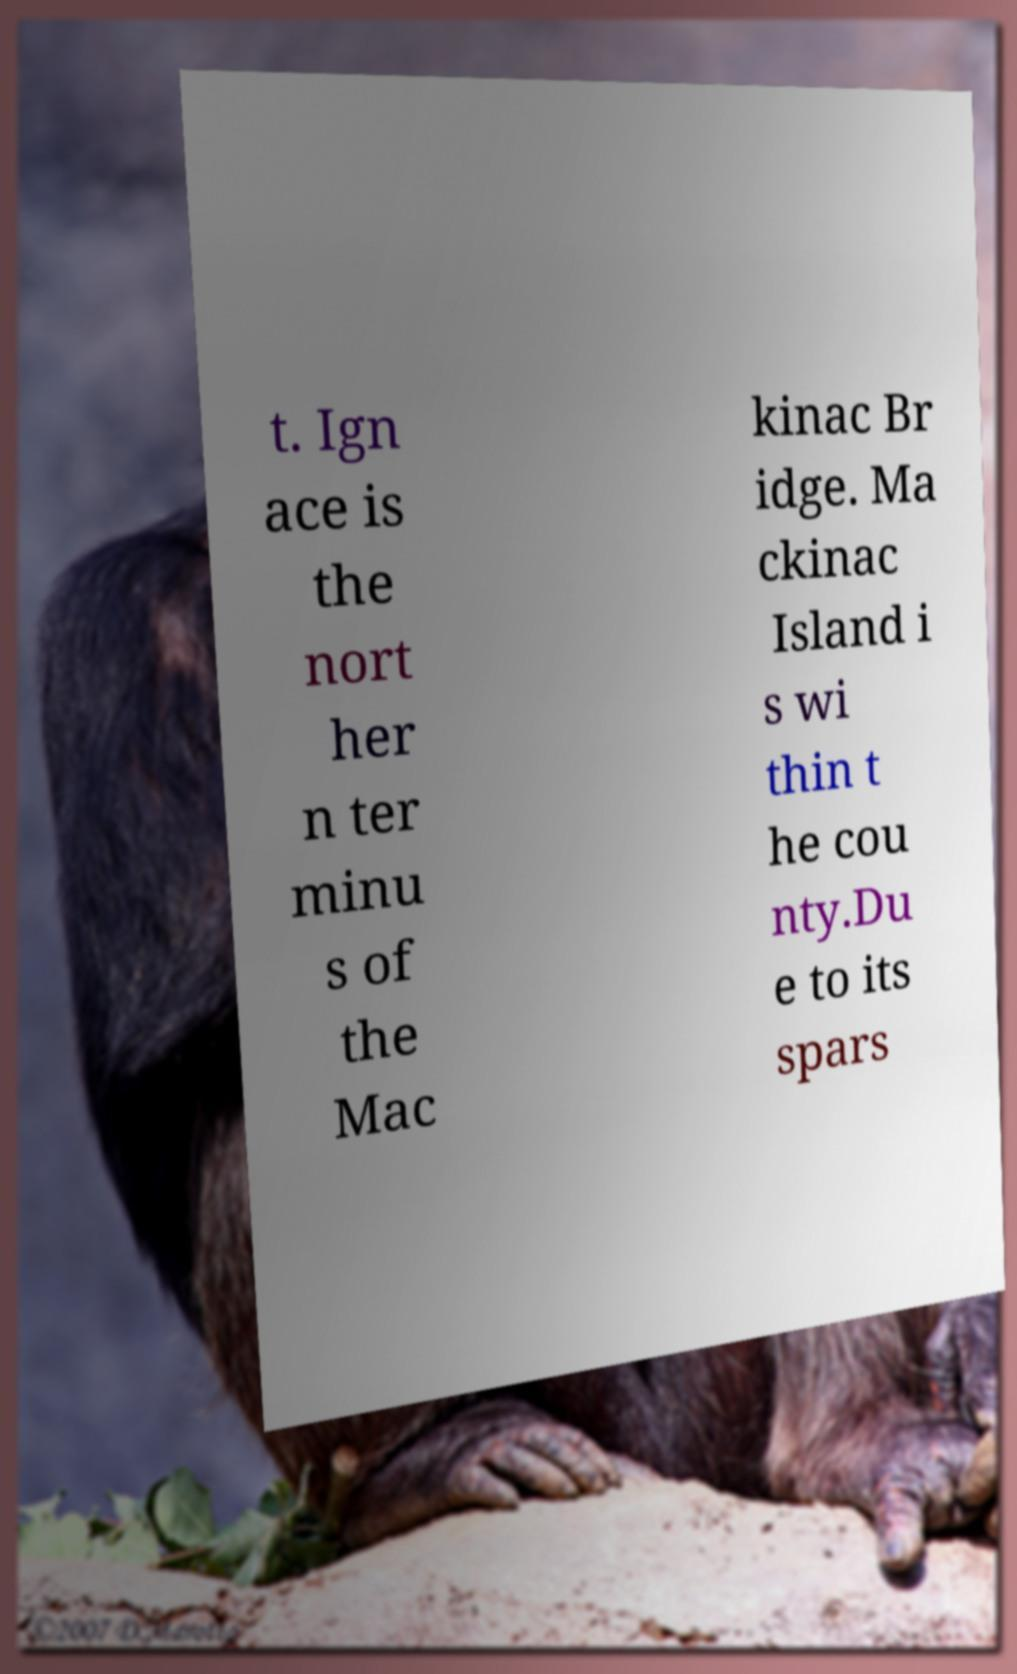Can you accurately transcribe the text from the provided image for me? t. Ign ace is the nort her n ter minu s of the Mac kinac Br idge. Ma ckinac Island i s wi thin t he cou nty.Du e to its spars 